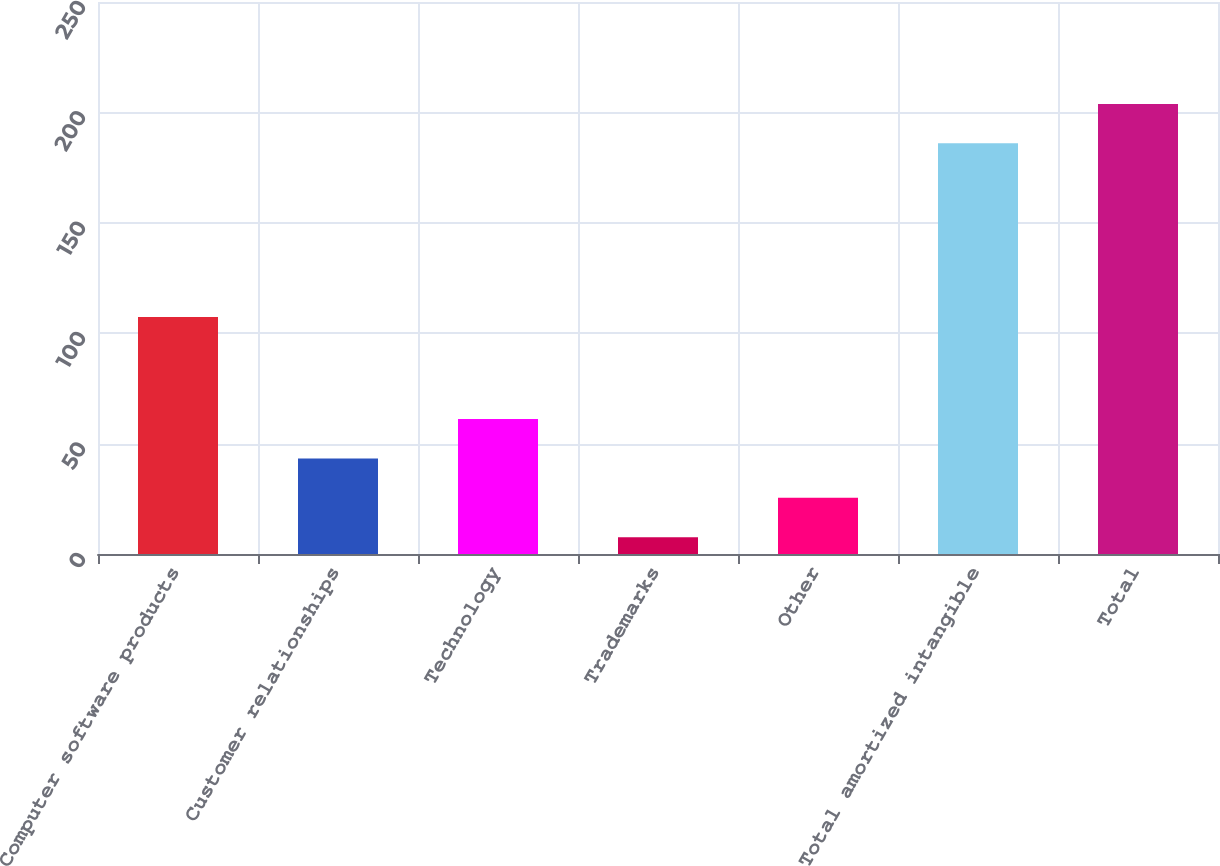Convert chart to OTSL. <chart><loc_0><loc_0><loc_500><loc_500><bar_chart><fcel>Computer software products<fcel>Customer relationships<fcel>Technology<fcel>Trademarks<fcel>Other<fcel>Total amortized intangible<fcel>Total<nl><fcel>107.3<fcel>43.28<fcel>61.12<fcel>7.6<fcel>25.44<fcel>186<fcel>203.84<nl></chart> 